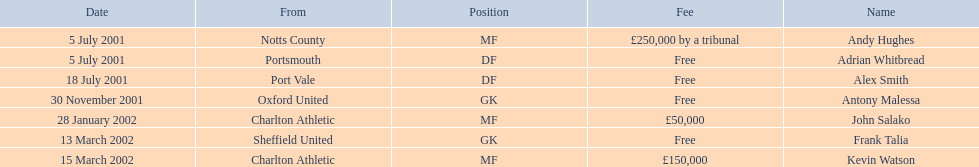What are the names of all the players? Andy Hughes, Adrian Whitbread, Alex Smith, Antony Malessa, John Salako, Frank Talia, Kevin Watson. What fee did andy hughes command? £250,000 by a tribunal. What fee did john salako command? £50,000. Which player had the highest fee, andy hughes or john salako? Andy Hughes. 